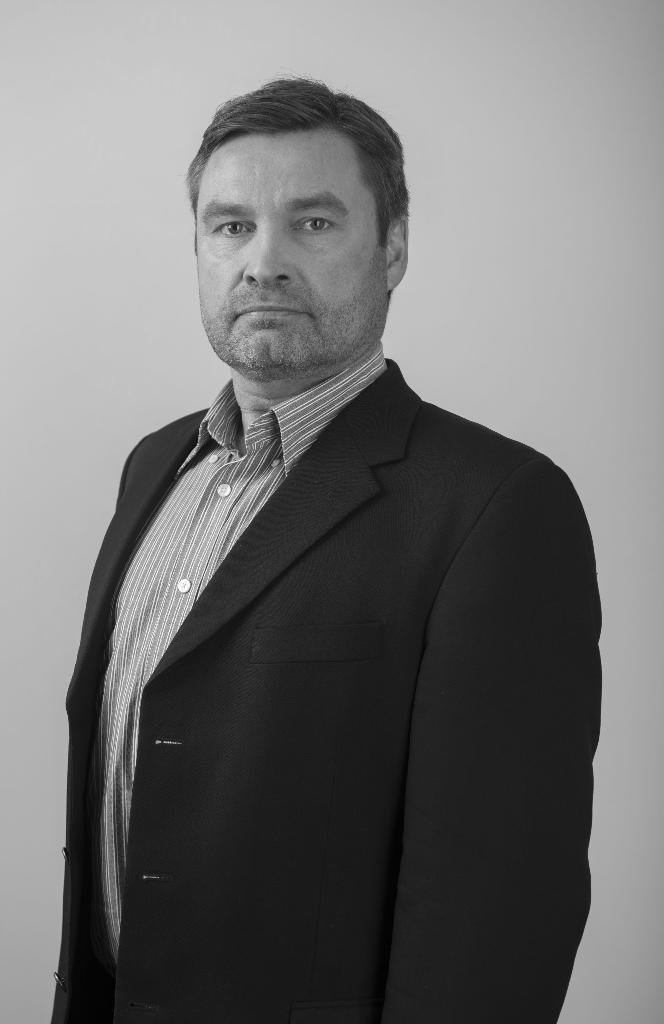What is the color scheme of the image? The image is black and white. Can you describe the main subject in the image? There is a person in the image. What can be seen behind the person in the image? There is a background in the image. How many grapes are on the person's head in the image? There are no grapes present in the image. What type of man is depicted in the image? The image does not provide enough information to determine the person's gender or any specific characteristics. --- Facts: 1. There is a car in the image. 2. The car is red. 3. The car has four wheels. 4. There is a road in the image. 5. The road is paved. Absurd Topics: bird, ocean, mountain Conversation: What is the main subject in the image? There is a car in the image. What color is the car? The car is red. How many wheels does the car have? The car has four wheels. What can be seen in the background of the image? There is a road in the image. What type of surface is the road made of? The road is paved. Reasoning: Let's think step by step in order to produce the conversation. We start by identifying the main subject in the image, which is a car. Then, we describe the car's color and the number of wheels it has. Next, we mention the background, which is a road. Finally, we provide information about the road's surface, which is paved. Each question is designed to elicit a specific detail about the image that is known from the provided facts. Absurd Question/Answer: Can you see any birds flying over the ocean in the image? There is no ocean or birds present in the image. Is there a mountain visible in the background of the image? There is no mountain present in the image. 